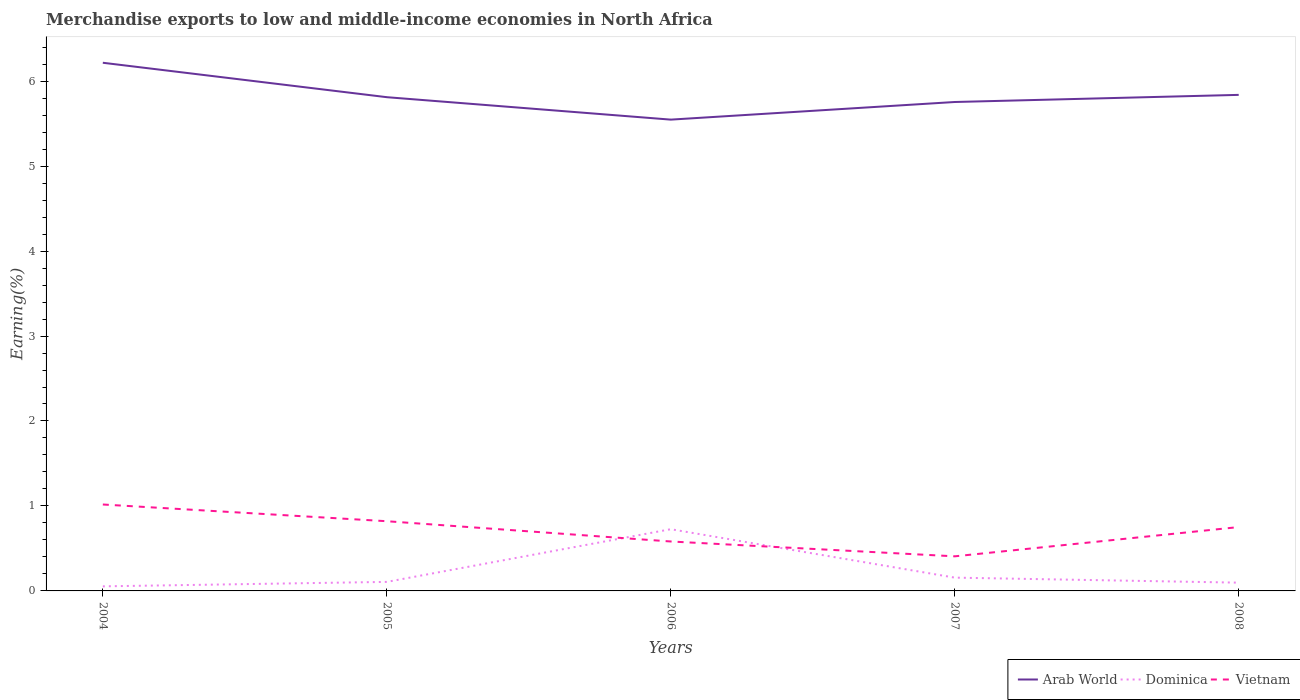How many different coloured lines are there?
Your response must be concise. 3. Across all years, what is the maximum percentage of amount earned from merchandise exports in Dominica?
Offer a terse response. 0.05. In which year was the percentage of amount earned from merchandise exports in Vietnam maximum?
Make the answer very short. 2007. What is the total percentage of amount earned from merchandise exports in Arab World in the graph?
Offer a terse response. 0.46. What is the difference between the highest and the second highest percentage of amount earned from merchandise exports in Dominica?
Your answer should be very brief. 0.67. How many lines are there?
Offer a terse response. 3. Does the graph contain grids?
Provide a short and direct response. No. Where does the legend appear in the graph?
Provide a short and direct response. Bottom right. How many legend labels are there?
Your answer should be compact. 3. How are the legend labels stacked?
Provide a short and direct response. Horizontal. What is the title of the graph?
Ensure brevity in your answer.  Merchandise exports to low and middle-income economies in North Africa. What is the label or title of the X-axis?
Your response must be concise. Years. What is the label or title of the Y-axis?
Provide a short and direct response. Earning(%). What is the Earning(%) of Arab World in 2004?
Your answer should be very brief. 6.22. What is the Earning(%) in Dominica in 2004?
Your response must be concise. 0.05. What is the Earning(%) in Vietnam in 2004?
Your answer should be compact. 1.02. What is the Earning(%) of Arab World in 2005?
Your answer should be compact. 5.81. What is the Earning(%) in Dominica in 2005?
Offer a terse response. 0.11. What is the Earning(%) of Vietnam in 2005?
Give a very brief answer. 0.82. What is the Earning(%) of Arab World in 2006?
Ensure brevity in your answer.  5.55. What is the Earning(%) of Dominica in 2006?
Make the answer very short. 0.73. What is the Earning(%) of Vietnam in 2006?
Give a very brief answer. 0.58. What is the Earning(%) in Arab World in 2007?
Your response must be concise. 5.75. What is the Earning(%) of Dominica in 2007?
Offer a very short reply. 0.16. What is the Earning(%) in Vietnam in 2007?
Your answer should be compact. 0.41. What is the Earning(%) in Arab World in 2008?
Your answer should be compact. 5.84. What is the Earning(%) of Dominica in 2008?
Give a very brief answer. 0.1. What is the Earning(%) in Vietnam in 2008?
Your answer should be compact. 0.75. Across all years, what is the maximum Earning(%) in Arab World?
Keep it short and to the point. 6.22. Across all years, what is the maximum Earning(%) of Dominica?
Keep it short and to the point. 0.73. Across all years, what is the maximum Earning(%) in Vietnam?
Provide a short and direct response. 1.02. Across all years, what is the minimum Earning(%) of Arab World?
Keep it short and to the point. 5.55. Across all years, what is the minimum Earning(%) in Dominica?
Your answer should be very brief. 0.05. Across all years, what is the minimum Earning(%) of Vietnam?
Keep it short and to the point. 0.41. What is the total Earning(%) of Arab World in the graph?
Ensure brevity in your answer.  29.17. What is the total Earning(%) of Dominica in the graph?
Your answer should be very brief. 1.14. What is the total Earning(%) in Vietnam in the graph?
Offer a very short reply. 3.58. What is the difference between the Earning(%) in Arab World in 2004 and that in 2005?
Provide a short and direct response. 0.41. What is the difference between the Earning(%) of Dominica in 2004 and that in 2005?
Keep it short and to the point. -0.05. What is the difference between the Earning(%) in Vietnam in 2004 and that in 2005?
Give a very brief answer. 0.2. What is the difference between the Earning(%) of Arab World in 2004 and that in 2006?
Your answer should be compact. 0.67. What is the difference between the Earning(%) in Dominica in 2004 and that in 2006?
Ensure brevity in your answer.  -0.67. What is the difference between the Earning(%) of Vietnam in 2004 and that in 2006?
Give a very brief answer. 0.44. What is the difference between the Earning(%) in Arab World in 2004 and that in 2007?
Provide a succinct answer. 0.46. What is the difference between the Earning(%) in Dominica in 2004 and that in 2007?
Provide a short and direct response. -0.1. What is the difference between the Earning(%) in Vietnam in 2004 and that in 2007?
Provide a short and direct response. 0.61. What is the difference between the Earning(%) in Arab World in 2004 and that in 2008?
Give a very brief answer. 0.38. What is the difference between the Earning(%) of Dominica in 2004 and that in 2008?
Ensure brevity in your answer.  -0.04. What is the difference between the Earning(%) of Vietnam in 2004 and that in 2008?
Offer a very short reply. 0.27. What is the difference between the Earning(%) in Arab World in 2005 and that in 2006?
Offer a very short reply. 0.26. What is the difference between the Earning(%) in Dominica in 2005 and that in 2006?
Give a very brief answer. -0.62. What is the difference between the Earning(%) in Vietnam in 2005 and that in 2006?
Your response must be concise. 0.24. What is the difference between the Earning(%) of Arab World in 2005 and that in 2007?
Provide a short and direct response. 0.06. What is the difference between the Earning(%) in Dominica in 2005 and that in 2007?
Offer a terse response. -0.05. What is the difference between the Earning(%) of Vietnam in 2005 and that in 2007?
Make the answer very short. 0.41. What is the difference between the Earning(%) in Arab World in 2005 and that in 2008?
Make the answer very short. -0.03. What is the difference between the Earning(%) of Dominica in 2005 and that in 2008?
Give a very brief answer. 0.01. What is the difference between the Earning(%) in Vietnam in 2005 and that in 2008?
Ensure brevity in your answer.  0.07. What is the difference between the Earning(%) of Arab World in 2006 and that in 2007?
Your answer should be very brief. -0.21. What is the difference between the Earning(%) in Dominica in 2006 and that in 2007?
Provide a succinct answer. 0.57. What is the difference between the Earning(%) of Vietnam in 2006 and that in 2007?
Your answer should be very brief. 0.17. What is the difference between the Earning(%) in Arab World in 2006 and that in 2008?
Keep it short and to the point. -0.29. What is the difference between the Earning(%) in Dominica in 2006 and that in 2008?
Ensure brevity in your answer.  0.63. What is the difference between the Earning(%) in Vietnam in 2006 and that in 2008?
Ensure brevity in your answer.  -0.17. What is the difference between the Earning(%) of Arab World in 2007 and that in 2008?
Your answer should be compact. -0.08. What is the difference between the Earning(%) in Dominica in 2007 and that in 2008?
Ensure brevity in your answer.  0.06. What is the difference between the Earning(%) of Vietnam in 2007 and that in 2008?
Keep it short and to the point. -0.34. What is the difference between the Earning(%) of Arab World in 2004 and the Earning(%) of Dominica in 2005?
Your answer should be compact. 6.11. What is the difference between the Earning(%) of Arab World in 2004 and the Earning(%) of Vietnam in 2005?
Make the answer very short. 5.4. What is the difference between the Earning(%) of Dominica in 2004 and the Earning(%) of Vietnam in 2005?
Provide a succinct answer. -0.77. What is the difference between the Earning(%) of Arab World in 2004 and the Earning(%) of Dominica in 2006?
Offer a very short reply. 5.49. What is the difference between the Earning(%) in Arab World in 2004 and the Earning(%) in Vietnam in 2006?
Provide a succinct answer. 5.63. What is the difference between the Earning(%) in Dominica in 2004 and the Earning(%) in Vietnam in 2006?
Offer a very short reply. -0.53. What is the difference between the Earning(%) of Arab World in 2004 and the Earning(%) of Dominica in 2007?
Offer a very short reply. 6.06. What is the difference between the Earning(%) in Arab World in 2004 and the Earning(%) in Vietnam in 2007?
Provide a short and direct response. 5.81. What is the difference between the Earning(%) of Dominica in 2004 and the Earning(%) of Vietnam in 2007?
Give a very brief answer. -0.35. What is the difference between the Earning(%) in Arab World in 2004 and the Earning(%) in Dominica in 2008?
Keep it short and to the point. 6.12. What is the difference between the Earning(%) in Arab World in 2004 and the Earning(%) in Vietnam in 2008?
Make the answer very short. 5.46. What is the difference between the Earning(%) in Dominica in 2004 and the Earning(%) in Vietnam in 2008?
Your answer should be compact. -0.7. What is the difference between the Earning(%) in Arab World in 2005 and the Earning(%) in Dominica in 2006?
Keep it short and to the point. 5.08. What is the difference between the Earning(%) in Arab World in 2005 and the Earning(%) in Vietnam in 2006?
Your response must be concise. 5.23. What is the difference between the Earning(%) in Dominica in 2005 and the Earning(%) in Vietnam in 2006?
Offer a very short reply. -0.48. What is the difference between the Earning(%) in Arab World in 2005 and the Earning(%) in Dominica in 2007?
Your response must be concise. 5.65. What is the difference between the Earning(%) in Arab World in 2005 and the Earning(%) in Vietnam in 2007?
Offer a terse response. 5.4. What is the difference between the Earning(%) in Dominica in 2005 and the Earning(%) in Vietnam in 2007?
Your answer should be compact. -0.3. What is the difference between the Earning(%) in Arab World in 2005 and the Earning(%) in Dominica in 2008?
Give a very brief answer. 5.71. What is the difference between the Earning(%) in Arab World in 2005 and the Earning(%) in Vietnam in 2008?
Offer a terse response. 5.06. What is the difference between the Earning(%) in Dominica in 2005 and the Earning(%) in Vietnam in 2008?
Ensure brevity in your answer.  -0.65. What is the difference between the Earning(%) of Arab World in 2006 and the Earning(%) of Dominica in 2007?
Make the answer very short. 5.39. What is the difference between the Earning(%) of Arab World in 2006 and the Earning(%) of Vietnam in 2007?
Make the answer very short. 5.14. What is the difference between the Earning(%) in Dominica in 2006 and the Earning(%) in Vietnam in 2007?
Keep it short and to the point. 0.32. What is the difference between the Earning(%) in Arab World in 2006 and the Earning(%) in Dominica in 2008?
Offer a terse response. 5.45. What is the difference between the Earning(%) of Arab World in 2006 and the Earning(%) of Vietnam in 2008?
Your answer should be compact. 4.8. What is the difference between the Earning(%) in Dominica in 2006 and the Earning(%) in Vietnam in 2008?
Ensure brevity in your answer.  -0.03. What is the difference between the Earning(%) in Arab World in 2007 and the Earning(%) in Dominica in 2008?
Keep it short and to the point. 5.66. What is the difference between the Earning(%) of Arab World in 2007 and the Earning(%) of Vietnam in 2008?
Your answer should be compact. 5. What is the difference between the Earning(%) of Dominica in 2007 and the Earning(%) of Vietnam in 2008?
Your response must be concise. -0.6. What is the average Earning(%) in Arab World per year?
Provide a succinct answer. 5.83. What is the average Earning(%) of Dominica per year?
Make the answer very short. 0.23. What is the average Earning(%) in Vietnam per year?
Give a very brief answer. 0.72. In the year 2004, what is the difference between the Earning(%) of Arab World and Earning(%) of Dominica?
Offer a very short reply. 6.16. In the year 2004, what is the difference between the Earning(%) in Arab World and Earning(%) in Vietnam?
Make the answer very short. 5.2. In the year 2004, what is the difference between the Earning(%) in Dominica and Earning(%) in Vietnam?
Your answer should be compact. -0.96. In the year 2005, what is the difference between the Earning(%) in Arab World and Earning(%) in Dominica?
Give a very brief answer. 5.7. In the year 2005, what is the difference between the Earning(%) of Arab World and Earning(%) of Vietnam?
Make the answer very short. 4.99. In the year 2005, what is the difference between the Earning(%) of Dominica and Earning(%) of Vietnam?
Provide a succinct answer. -0.71. In the year 2006, what is the difference between the Earning(%) of Arab World and Earning(%) of Dominica?
Keep it short and to the point. 4.82. In the year 2006, what is the difference between the Earning(%) in Arab World and Earning(%) in Vietnam?
Ensure brevity in your answer.  4.97. In the year 2006, what is the difference between the Earning(%) in Dominica and Earning(%) in Vietnam?
Ensure brevity in your answer.  0.14. In the year 2007, what is the difference between the Earning(%) of Arab World and Earning(%) of Dominica?
Your answer should be very brief. 5.6. In the year 2007, what is the difference between the Earning(%) of Arab World and Earning(%) of Vietnam?
Keep it short and to the point. 5.35. In the year 2007, what is the difference between the Earning(%) of Dominica and Earning(%) of Vietnam?
Keep it short and to the point. -0.25. In the year 2008, what is the difference between the Earning(%) in Arab World and Earning(%) in Dominica?
Your response must be concise. 5.74. In the year 2008, what is the difference between the Earning(%) of Arab World and Earning(%) of Vietnam?
Provide a short and direct response. 5.09. In the year 2008, what is the difference between the Earning(%) of Dominica and Earning(%) of Vietnam?
Make the answer very short. -0.65. What is the ratio of the Earning(%) of Arab World in 2004 to that in 2005?
Your response must be concise. 1.07. What is the ratio of the Earning(%) in Dominica in 2004 to that in 2005?
Ensure brevity in your answer.  0.51. What is the ratio of the Earning(%) in Vietnam in 2004 to that in 2005?
Offer a terse response. 1.24. What is the ratio of the Earning(%) of Arab World in 2004 to that in 2006?
Provide a short and direct response. 1.12. What is the ratio of the Earning(%) of Dominica in 2004 to that in 2006?
Provide a succinct answer. 0.07. What is the ratio of the Earning(%) in Vietnam in 2004 to that in 2006?
Provide a succinct answer. 1.75. What is the ratio of the Earning(%) of Arab World in 2004 to that in 2007?
Your answer should be compact. 1.08. What is the ratio of the Earning(%) of Dominica in 2004 to that in 2007?
Offer a very short reply. 0.34. What is the ratio of the Earning(%) of Vietnam in 2004 to that in 2007?
Offer a very short reply. 2.5. What is the ratio of the Earning(%) of Arab World in 2004 to that in 2008?
Provide a succinct answer. 1.06. What is the ratio of the Earning(%) in Dominica in 2004 to that in 2008?
Offer a very short reply. 0.55. What is the ratio of the Earning(%) in Vietnam in 2004 to that in 2008?
Provide a succinct answer. 1.35. What is the ratio of the Earning(%) of Arab World in 2005 to that in 2006?
Keep it short and to the point. 1.05. What is the ratio of the Earning(%) in Dominica in 2005 to that in 2006?
Provide a succinct answer. 0.15. What is the ratio of the Earning(%) in Vietnam in 2005 to that in 2006?
Ensure brevity in your answer.  1.41. What is the ratio of the Earning(%) of Arab World in 2005 to that in 2007?
Provide a succinct answer. 1.01. What is the ratio of the Earning(%) of Dominica in 2005 to that in 2007?
Make the answer very short. 0.68. What is the ratio of the Earning(%) in Vietnam in 2005 to that in 2007?
Ensure brevity in your answer.  2.02. What is the ratio of the Earning(%) in Arab World in 2005 to that in 2008?
Keep it short and to the point. 1. What is the ratio of the Earning(%) of Dominica in 2005 to that in 2008?
Offer a terse response. 1.09. What is the ratio of the Earning(%) in Vietnam in 2005 to that in 2008?
Offer a terse response. 1.09. What is the ratio of the Earning(%) of Arab World in 2006 to that in 2007?
Keep it short and to the point. 0.96. What is the ratio of the Earning(%) in Dominica in 2006 to that in 2007?
Your response must be concise. 4.65. What is the ratio of the Earning(%) in Vietnam in 2006 to that in 2007?
Keep it short and to the point. 1.43. What is the ratio of the Earning(%) in Arab World in 2006 to that in 2008?
Your answer should be compact. 0.95. What is the ratio of the Earning(%) of Dominica in 2006 to that in 2008?
Make the answer very short. 7.46. What is the ratio of the Earning(%) in Vietnam in 2006 to that in 2008?
Keep it short and to the point. 0.77. What is the ratio of the Earning(%) of Arab World in 2007 to that in 2008?
Offer a terse response. 0.99. What is the ratio of the Earning(%) of Dominica in 2007 to that in 2008?
Your answer should be very brief. 1.61. What is the ratio of the Earning(%) of Vietnam in 2007 to that in 2008?
Offer a terse response. 0.54. What is the difference between the highest and the second highest Earning(%) in Arab World?
Keep it short and to the point. 0.38. What is the difference between the highest and the second highest Earning(%) in Dominica?
Give a very brief answer. 0.57. What is the difference between the highest and the second highest Earning(%) of Vietnam?
Your answer should be compact. 0.2. What is the difference between the highest and the lowest Earning(%) in Arab World?
Offer a very short reply. 0.67. What is the difference between the highest and the lowest Earning(%) of Dominica?
Provide a short and direct response. 0.67. What is the difference between the highest and the lowest Earning(%) in Vietnam?
Your answer should be very brief. 0.61. 